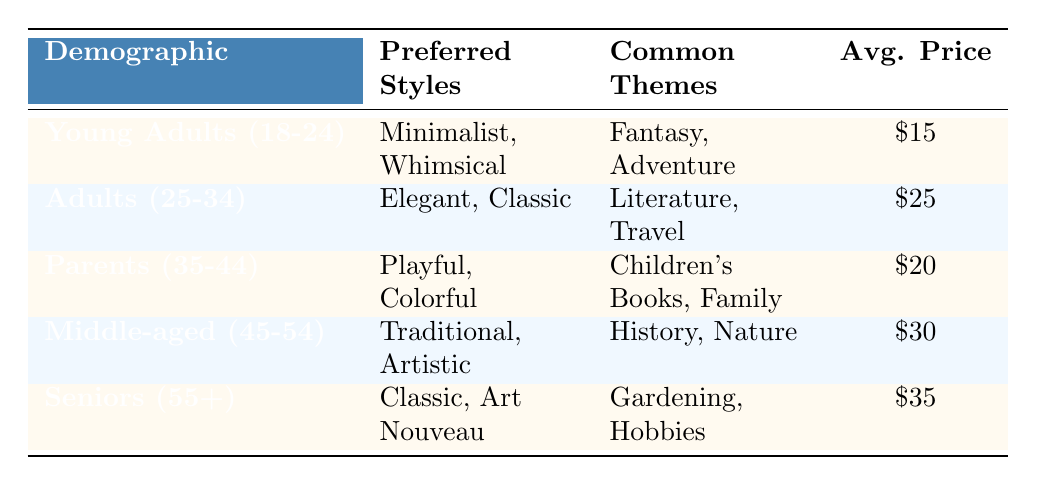What are the preferred styles for Seniors (55+)? The table shows that for Seniors (55+), the preferred styles are "Classic" and "Art Nouveau."
Answer: Classic, Art Nouveau Which customer demographic has the highest average price point for bookplate designs? By examining the table, Seniors (55+) have the highest average price point at $35, while the others have lower averages.
Answer: Seniors (55+) Do Young Adults (18-24) prefer playful styles? The table indicates that Young Adults (18-24) prefer "Minimalist" and "Whimsical" styles, but not "Playful," so the answer is no.
Answer: No What is the common theme for the Adults (25-34) demographic? According to the table, the common themes for Adults (25-34) are "Literature" and "Travel."
Answer: Literature, Travel What is the average price point for Parents (35-44) and Middle-aged (45-54)? The average price point for Parents (35-44) is $20 and for Middle-aged (45-54) is $30. Adding these gives 20 + 30 = 50, and dividing by 2 gives the average price point of 25.
Answer: 25 Which demographic's preferred styles include "Elegant"? Adults (25-34) have "Elegant" as one of their preferred styles according to the table.
Answer: Adults (25-34) Is the average price point for bookplates higher for Young Adults (18-24) than for Parents (35-44)? The average price point for Young Adults (18-24) is $15, while for Parents (35-44) it is $20. Therefore, $15 is not higher than $20, making the statement false.
Answer: No How many customer demographics prefer "Colorful" styles? From the table, it shows that only Parents (35-44) prefer "Colorful" styles. Thus, there is one demographic with this preference.
Answer: 1 What are the common themes for Middle-aged (45-54) customers? The common themes for Middle-aged (45-54) are "History" and "Nature" as listed in the table.
Answer: History, Nature 